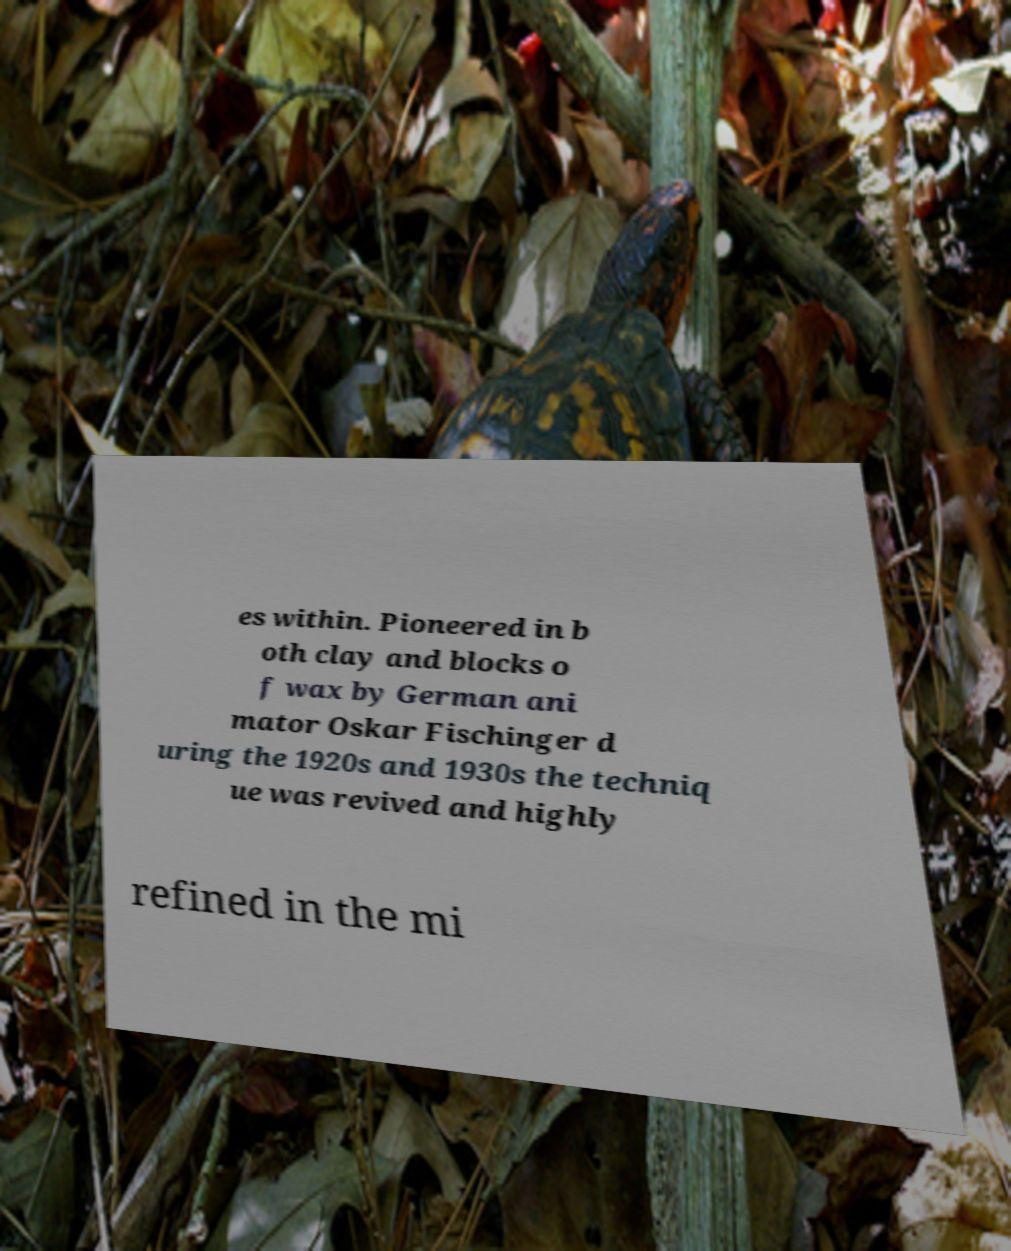I need the written content from this picture converted into text. Can you do that? es within. Pioneered in b oth clay and blocks o f wax by German ani mator Oskar Fischinger d uring the 1920s and 1930s the techniq ue was revived and highly refined in the mi 